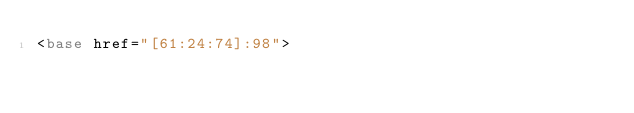<code> <loc_0><loc_0><loc_500><loc_500><_HTML_><base href="[61:24:74]:98">
</code> 